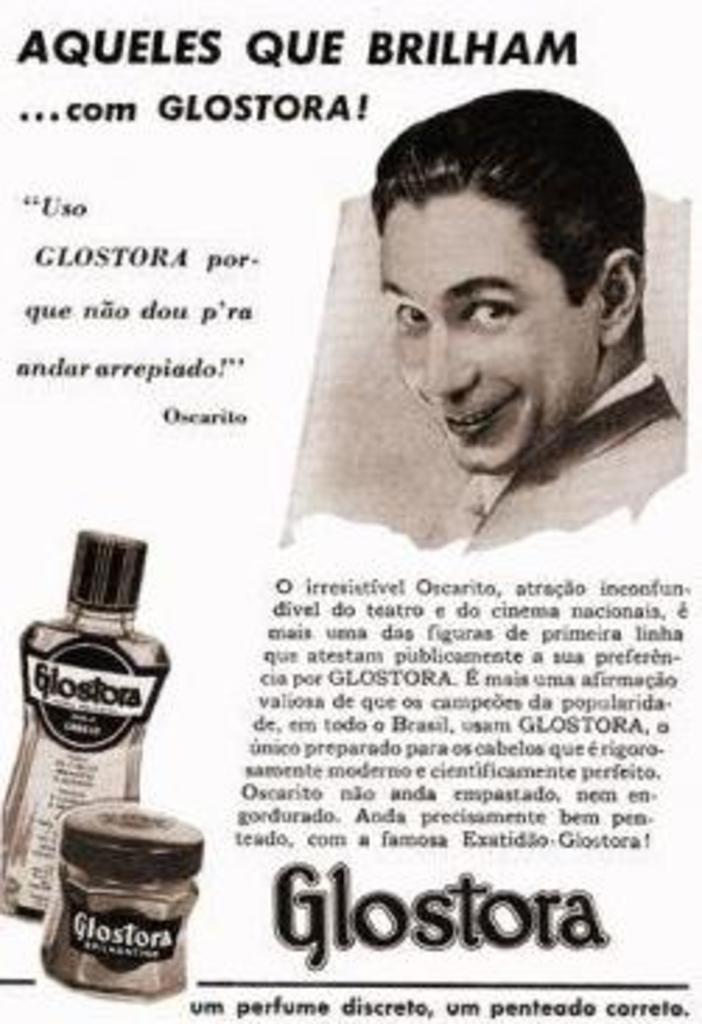<image>
Create a compact narrative representing the image presented. Advertisement showing a man's face and is titled "Aqueles Que Brilham". 